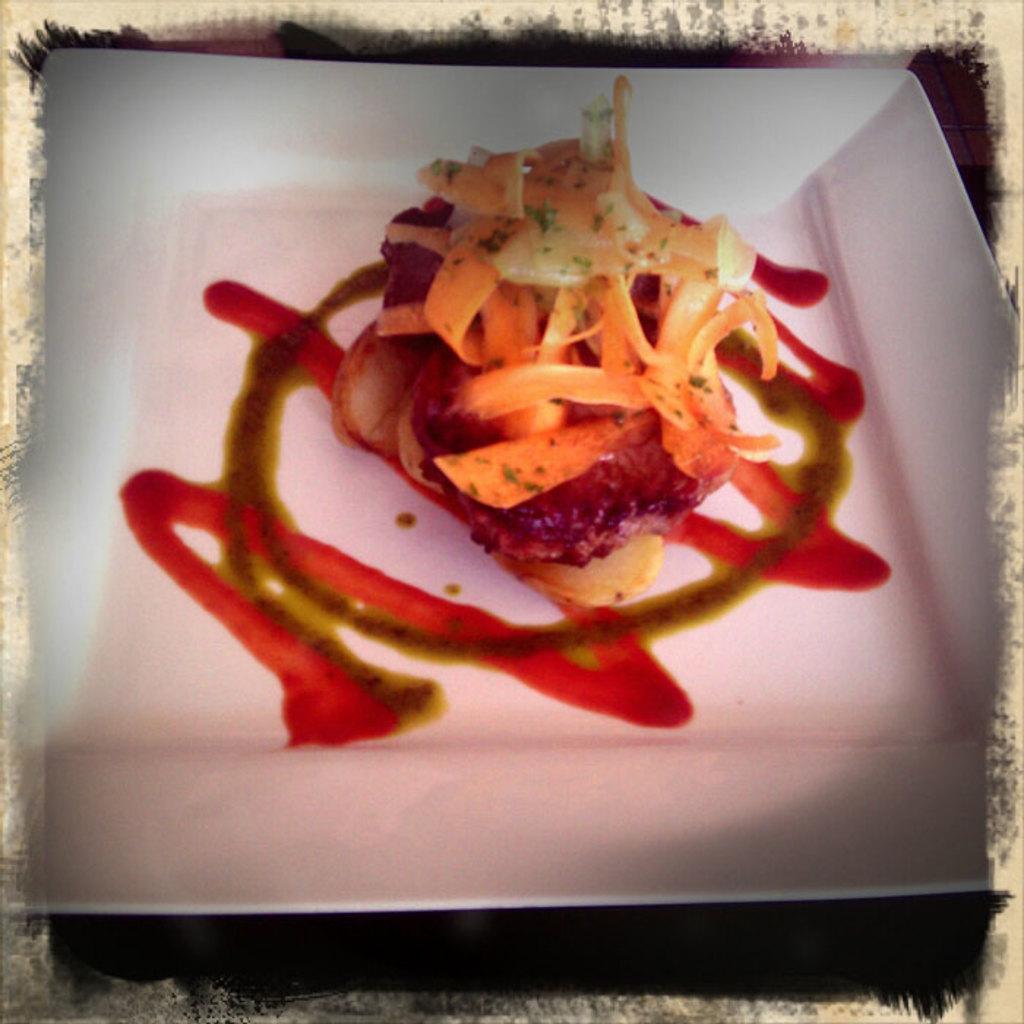Could you give a brief overview of what you see in this image? In the image we can see there is a food item kept in a plate. 